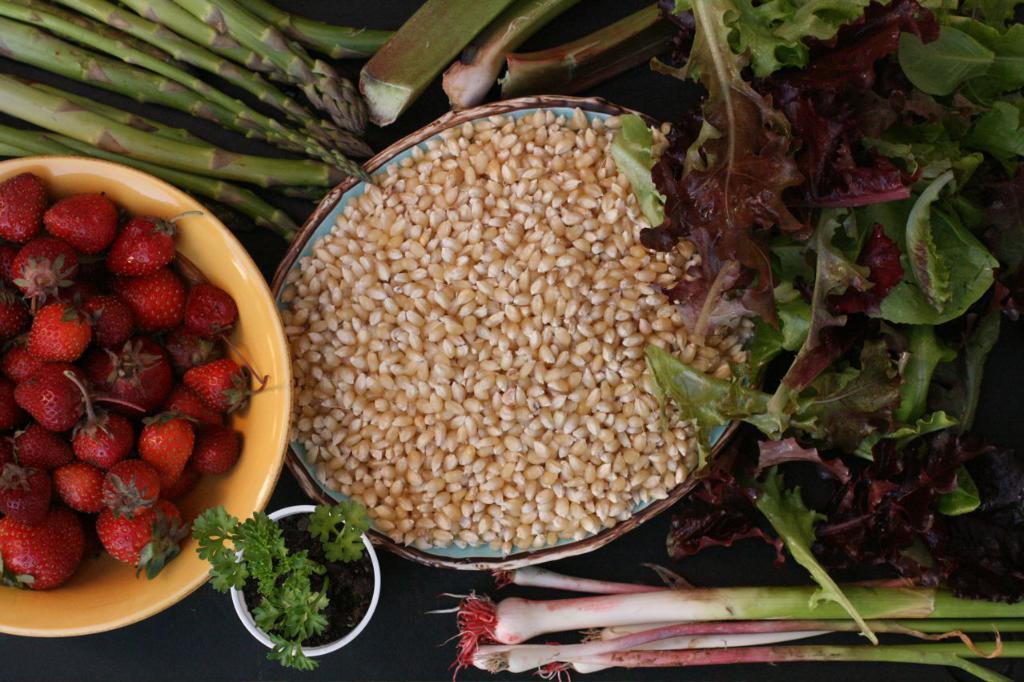Can you describe this image briefly? On the right there are leafy vegetables and other vegetables. In the center of the there are barley grains. On the left there are strawberries and other vegetables. In this picture there are bowls. 